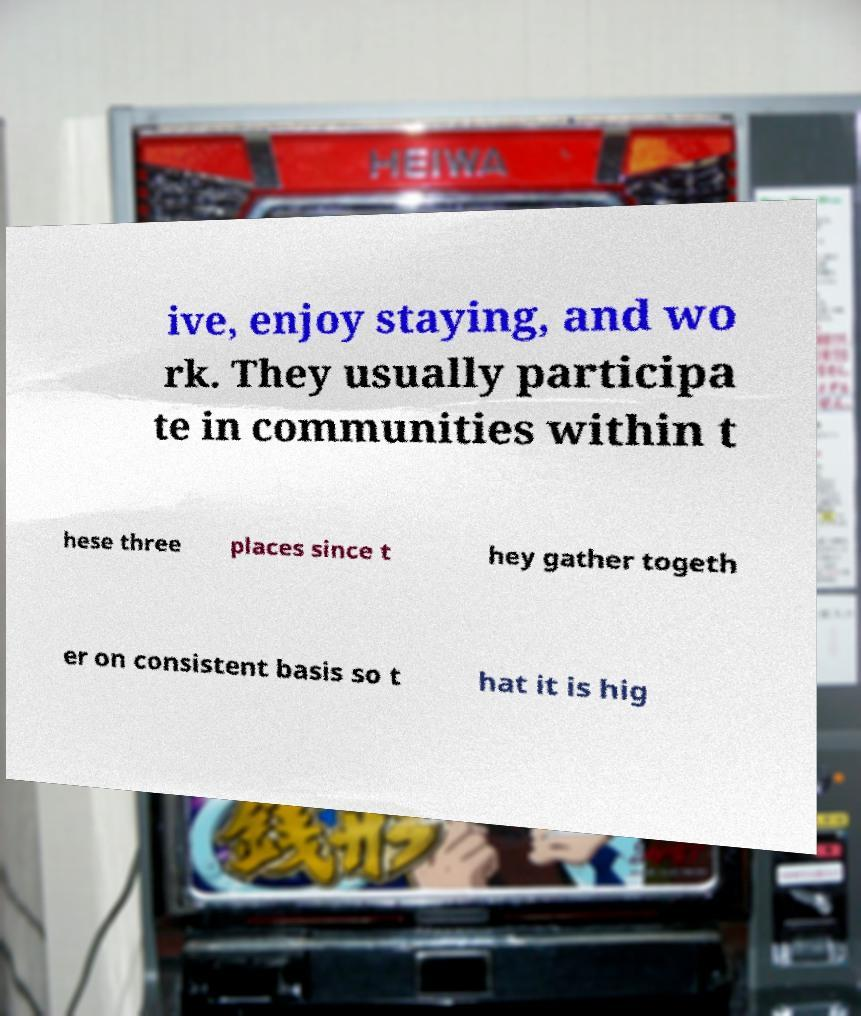Can you accurately transcribe the text from the provided image for me? ive, enjoy staying, and wo rk. They usually participa te in communities within t hese three places since t hey gather togeth er on consistent basis so t hat it is hig 